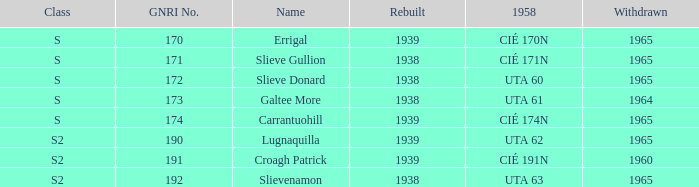What is the smallest withdrawn value with a GNRI greater than 172, name of Croagh Patrick and was rebuilt before 1939? None. 